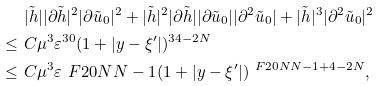<formula> <loc_0><loc_0><loc_500><loc_500>& \ | \tilde { h } | | \partial \tilde { h } | ^ { 2 } | \partial \tilde { u } _ { 0 } | ^ { 2 } + | \tilde { h } | ^ { 2 } | \partial \tilde { h } | | \partial \tilde { u } _ { 0 } | | \partial ^ { 2 } \tilde { u } _ { 0 } | + | \tilde { h } | ^ { 3 } | \partial ^ { 2 } \tilde { u } _ { 0 } | ^ { 2 } \\ \leq & \ C \mu ^ { 3 } \varepsilon ^ { 3 0 } ( 1 + | y - \xi ^ { \prime } | ) ^ { 3 4 - 2 N } \\ \leq & \ C \mu ^ { 3 } \varepsilon ^ { \ } F { 2 0 N } { N - 1 } ( 1 + | y - \xi ^ { \prime } | ) ^ { \ F { 2 0 N } { N - 1 } + 4 - 2 N } ,</formula> 